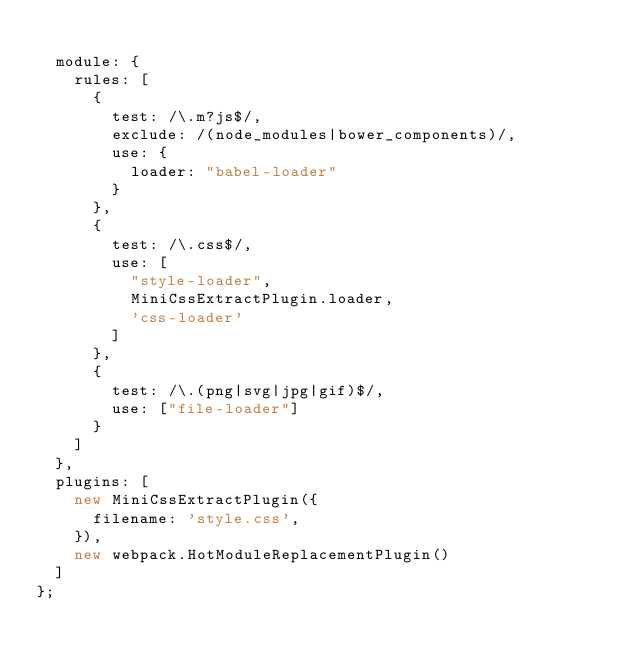Convert code to text. <code><loc_0><loc_0><loc_500><loc_500><_JavaScript_>
  module: {
    rules: [
      {
        test: /\.m?js$/,
        exclude: /(node_modules|bower_components)/,
        use: {
          loader: "babel-loader"
        }
      },
      {
        test: /\.css$/,
        use: [
          "style-loader",
          MiniCssExtractPlugin.loader,
          'css-loader'
        ]
      },
      {
        test: /\.(png|svg|jpg|gif)$/,
        use: ["file-loader"]
      }
    ]
  },
  plugins: [
    new MiniCssExtractPlugin({
      filename: 'style.css',
    }),
    new webpack.HotModuleReplacementPlugin()
  ]
};</code> 